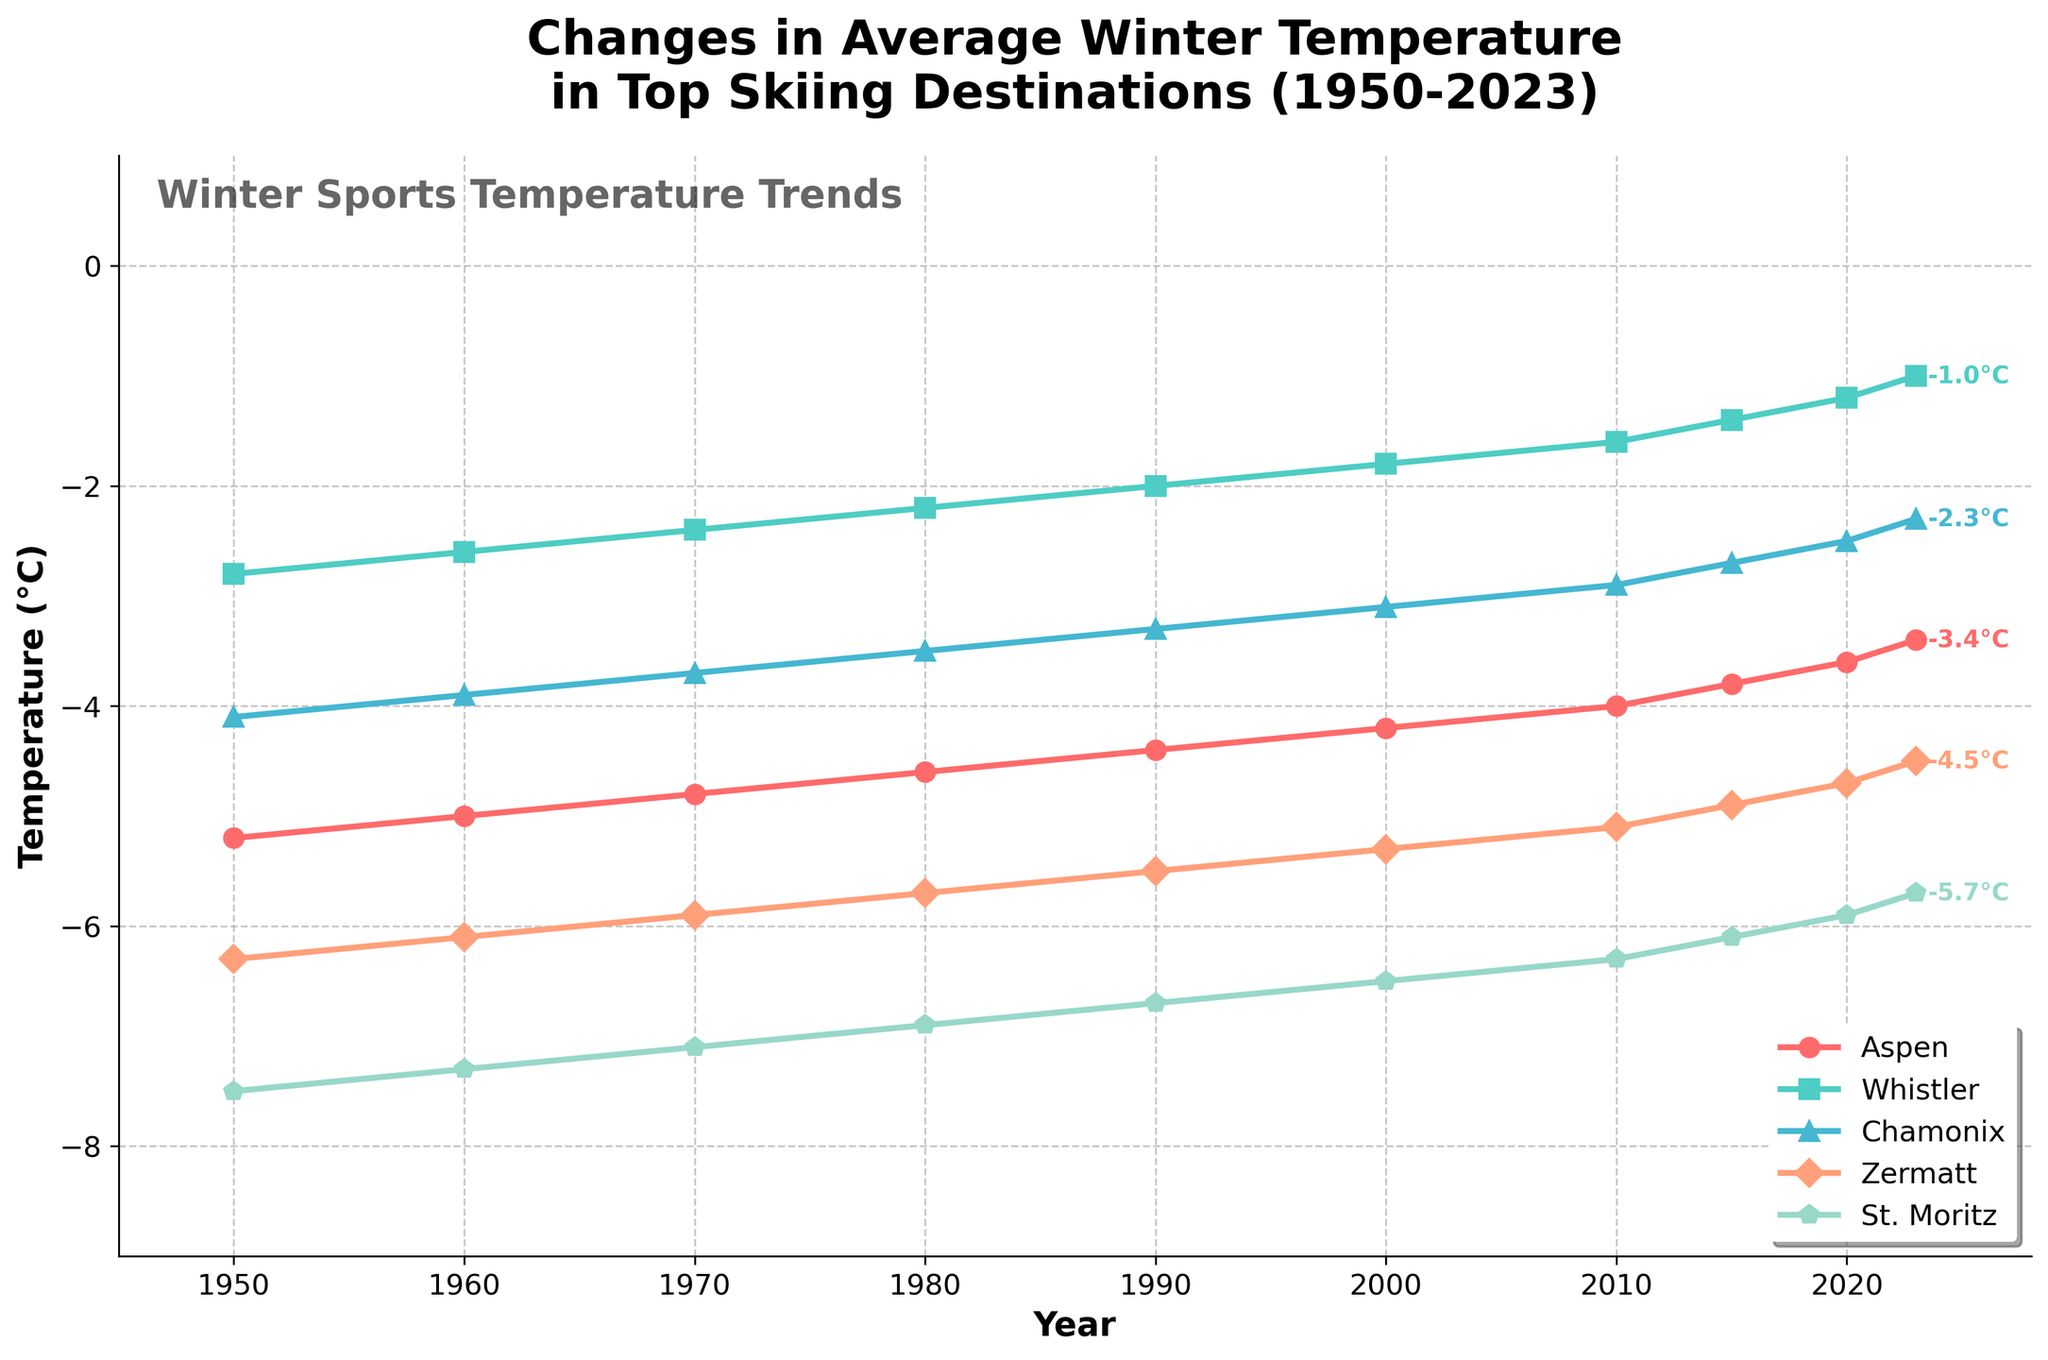How does the average temperature in Aspen in 1950 compare to 2023? To answer this, we look at the temperature data for Aspen in the two specified years. In 1950, the temperature is -5.2°C, and in 2023, it is -3.4°C. Comparing these, we see that the temperature has increased.
Answer: The temperature in Aspen increased by 1.8°C Which location had the highest average temperature in 2023? To determine this, we check the 2023 temperature values for all locations. Whistler has the highest average temperature at -1.0°C.
Answer: Whistler What is the range of average temperatures for Chamonix from 1950 to 2023? The range is calculated by subtracting the lowest temperature from the highest over the period. For Chamonix, the highest is -2.3°C (2023) and the lowest is -4.1°C (1950). The range is -2.3 - (-4.1) = 1.8°C.
Answer: 1.8°C Which skiing destination showed the most significant increase in temperature from 1950 to 2023? First, we compute the temperature change for each location: Aspen (1.8°C), Whistler (1.8°C), Chamonix (1.8°C), Zermatt (1.8°C), and St. Moritz (1.8°C). Since all values are equal, we can say they all exhibited the same temperature increase.
Answer: All destinations How has the average winter temperature in St. Moritz changed over the years? To answer this, we observe the trend line for St. Moritz from 1950 to 2023. The graph shows a consistent increase in temperature from -7.5°C in 1950 to -5.7°C in 2023.
Answer: Increased by 1.8°C Between 2010 and 2023, which location experienced the most significant change in average temperature? Calculating the difference for each location: 
Aspen: -3.4 - (-4.0) = 0.6°C, 
Whistler: -1.0 - (-1.6) = 0.6°C, 
Chamonix: -2.3 - (-2.9) = 0.6°C, 
Zermatt: -4.5 - (-5.1) = 0.6°C, 
St. Moritz: -5.7 - (-6.3) = 0.6°C. 
All locations experienced the same temperature change.
Answer: All locations equally What is the general trend in average temperatures for all locations over the studied period? Observing the lines for all destinations, we see a general increasing trend in average temperatures from 1950 to 2023.
Answer: Increasing In what year does Whistler exhibit the smallest temperature? Reviewing the temperature values for Whistler, the smallest is -2.8°C in 1950.
Answer: 1950 Which destination has the least change in temperature between 1950 and 2023? Calculating changes:
Aspen: 1.8°C, 
Whistler: 1.8°C,
Chamonix: 1.8°C,
Zermatt: 1.8°C,
St. Moritz: 1.8°C.
Every destination shows a uniform change in temperature over the years.
Answer: All destinations equally 